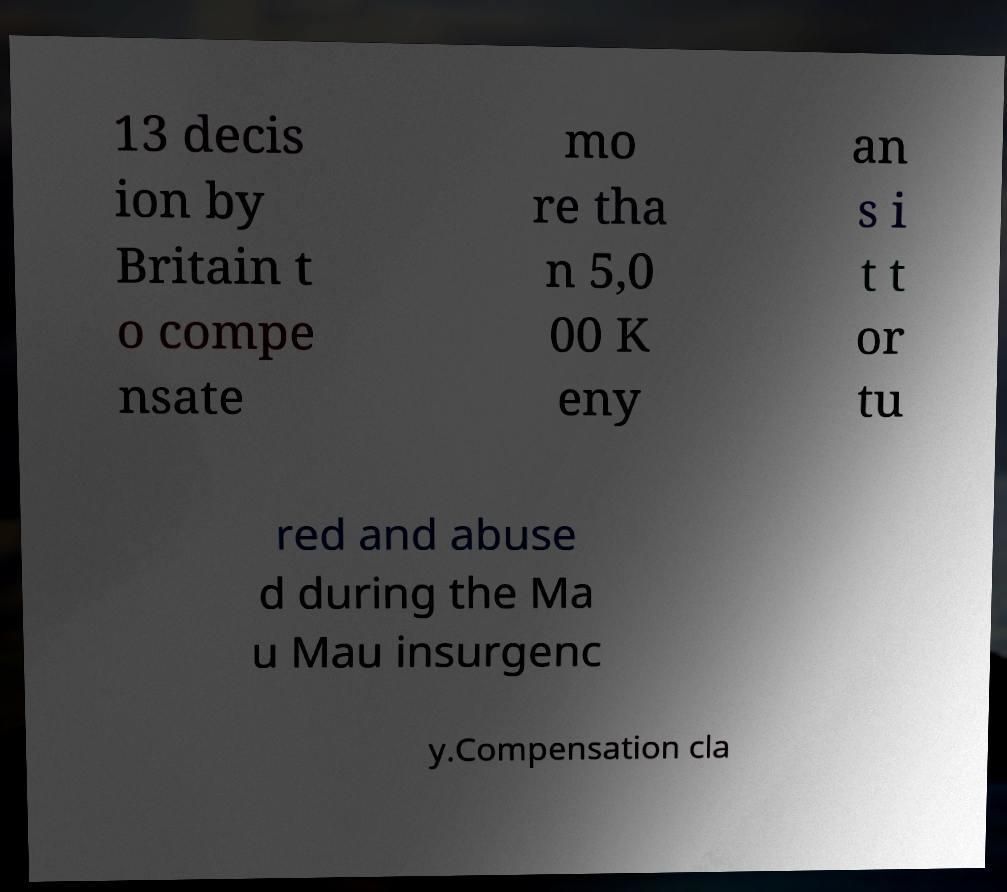Can you accurately transcribe the text from the provided image for me? 13 decis ion by Britain t o compe nsate mo re tha n 5,0 00 K eny an s i t t or tu red and abuse d during the Ma u Mau insurgenc y.Compensation cla 